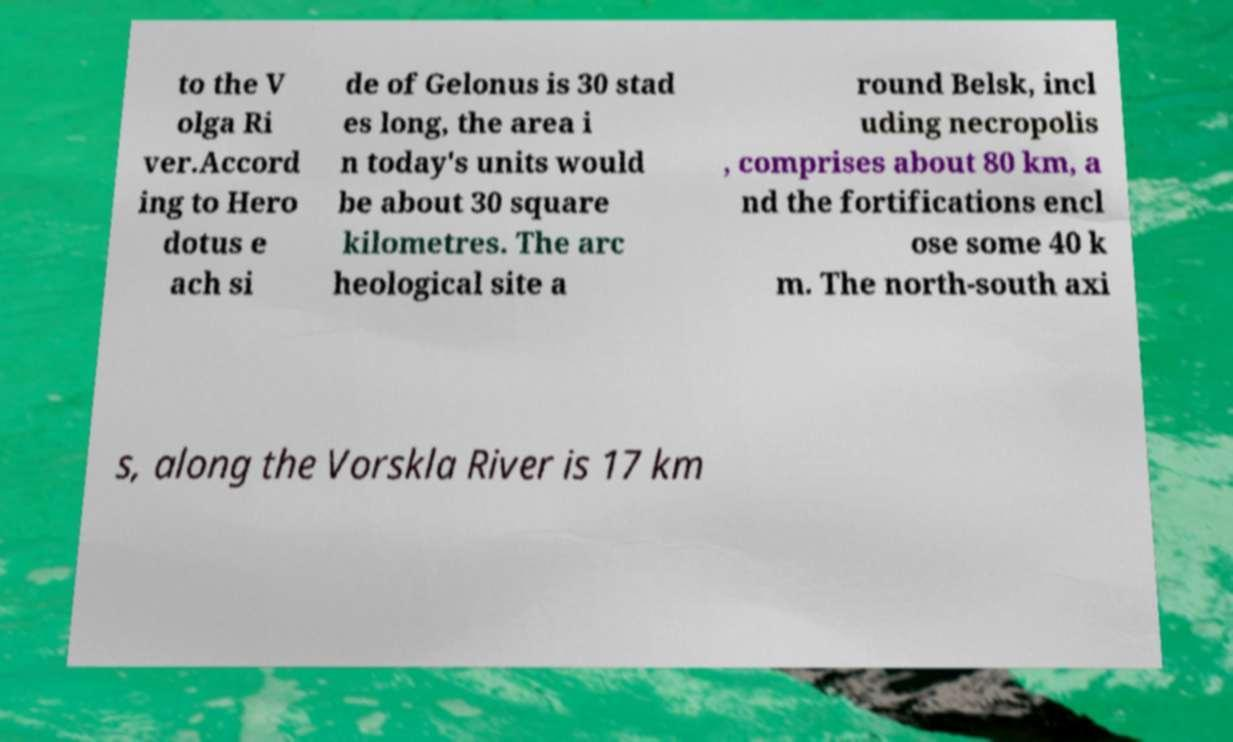Please identify and transcribe the text found in this image. to the V olga Ri ver.Accord ing to Hero dotus e ach si de of Gelonus is 30 stad es long, the area i n today's units would be about 30 square kilometres. The arc heological site a round Belsk, incl uding necropolis , comprises about 80 km, a nd the fortifications encl ose some 40 k m. The north-south axi s, along the Vorskla River is 17 km 